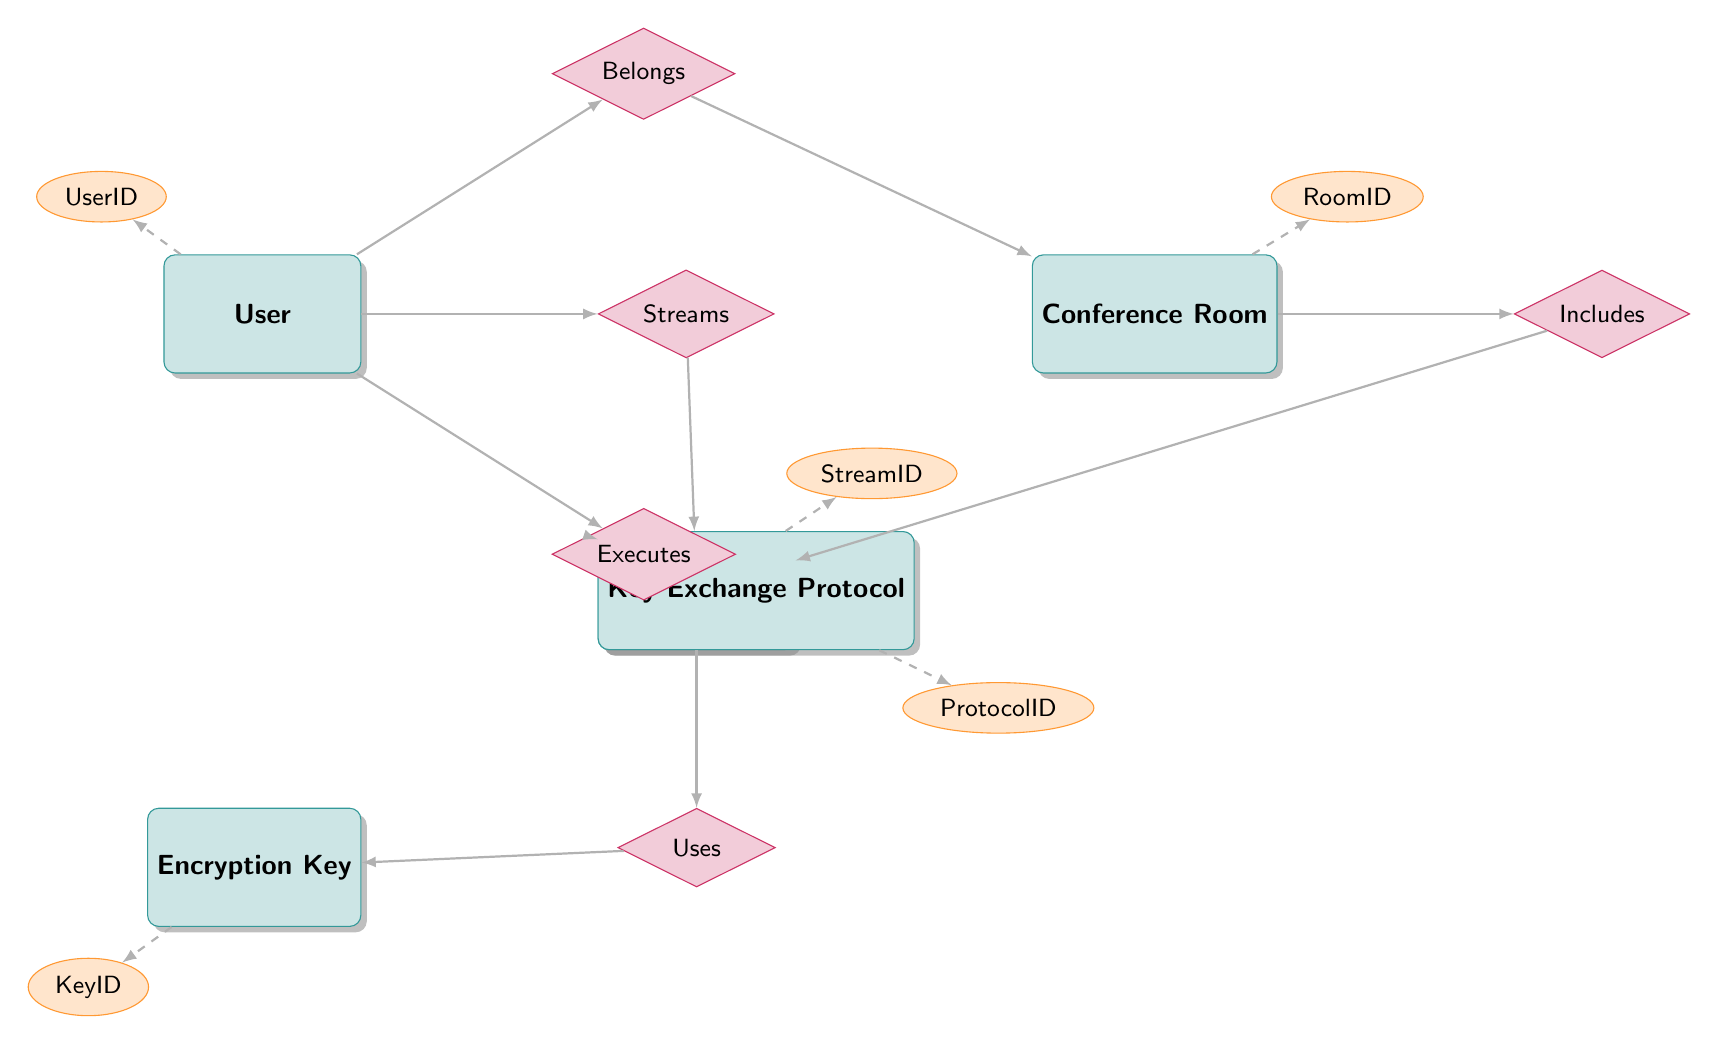What entities are present in the diagram? The diagram contains five entities: User, VideoStream, EncryptionKey, ConferenceRoom, and KeyExchangeProtocol.
Answer: User, VideoStream, EncryptionKey, ConferenceRoom, KeyExchangeProtocol How many relationships are depicted in the diagram? There are five relationships shown in the diagram: Streams, Includes, Uses, Executes, and Belongs.
Answer: 5 What is the role of the User in the "Executes" relationship? In the "Executes" relationship, the User serves as the initiator, indicating their active role in executing the KeyExchangeProtocol.
Answer: initiator Which entity has a relationship with both VideoStream and ConferenceRoom? The VideoStream entity has a relationship with the ConferenceRoom through the "Includes" relationship, indicating it is contained within a specific room.
Answer: VideoStream What attribute is associated with the EncryptionKey entity? The EncryptionKey entity has the attribute KeyID, which uniquely identifies different encryption keys used in the video conferencing system.
Answer: KeyID Which entity is directly linked to the Belongs relationship? The Belongs relationship directly links the User entity to the ConferenceRoom entity, indicating which users belong to which conference rooms.
Answer: ConferenceRoom What does the Uses relationship connect to? The Uses relationship connects the VideoStream entity to the EncryptionKey entity, indicating that a video stream utilizes a specific encryption key for securing data.
Answer: EncryptionKey In how many roles does the User participate within the diagram? The User participates in four roles: as an initiator in the Executes relationship, a member in the Belongs relationship, a source in the Streams relationship, and indirectly related to VideoStream through these associations.
Answer: 4 